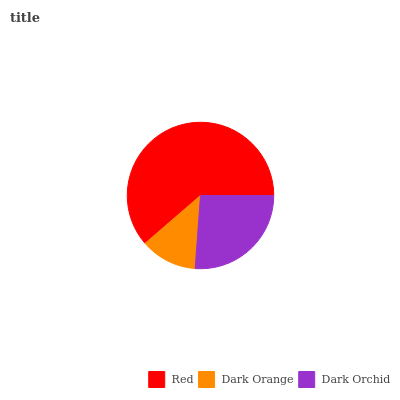Is Dark Orange the minimum?
Answer yes or no. Yes. Is Red the maximum?
Answer yes or no. Yes. Is Dark Orchid the minimum?
Answer yes or no. No. Is Dark Orchid the maximum?
Answer yes or no. No. Is Dark Orchid greater than Dark Orange?
Answer yes or no. Yes. Is Dark Orange less than Dark Orchid?
Answer yes or no. Yes. Is Dark Orange greater than Dark Orchid?
Answer yes or no. No. Is Dark Orchid less than Dark Orange?
Answer yes or no. No. Is Dark Orchid the high median?
Answer yes or no. Yes. Is Dark Orchid the low median?
Answer yes or no. Yes. Is Dark Orange the high median?
Answer yes or no. No. Is Red the low median?
Answer yes or no. No. 